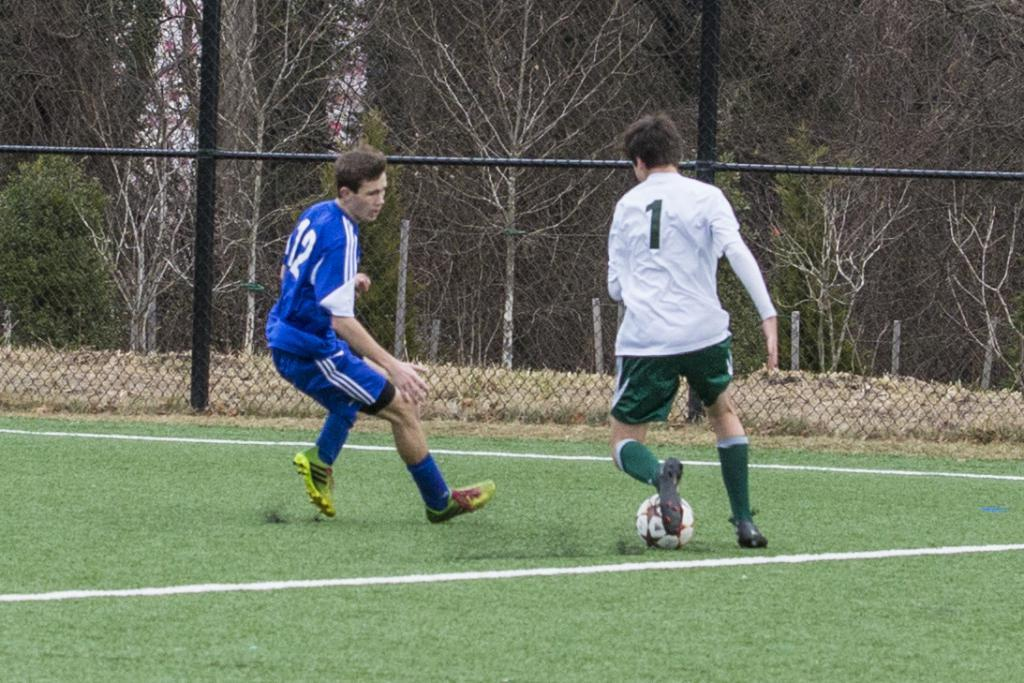<image>
Offer a succinct explanation of the picture presented. A man wearing a number 12 jersey is playing against someone wearing number 1 